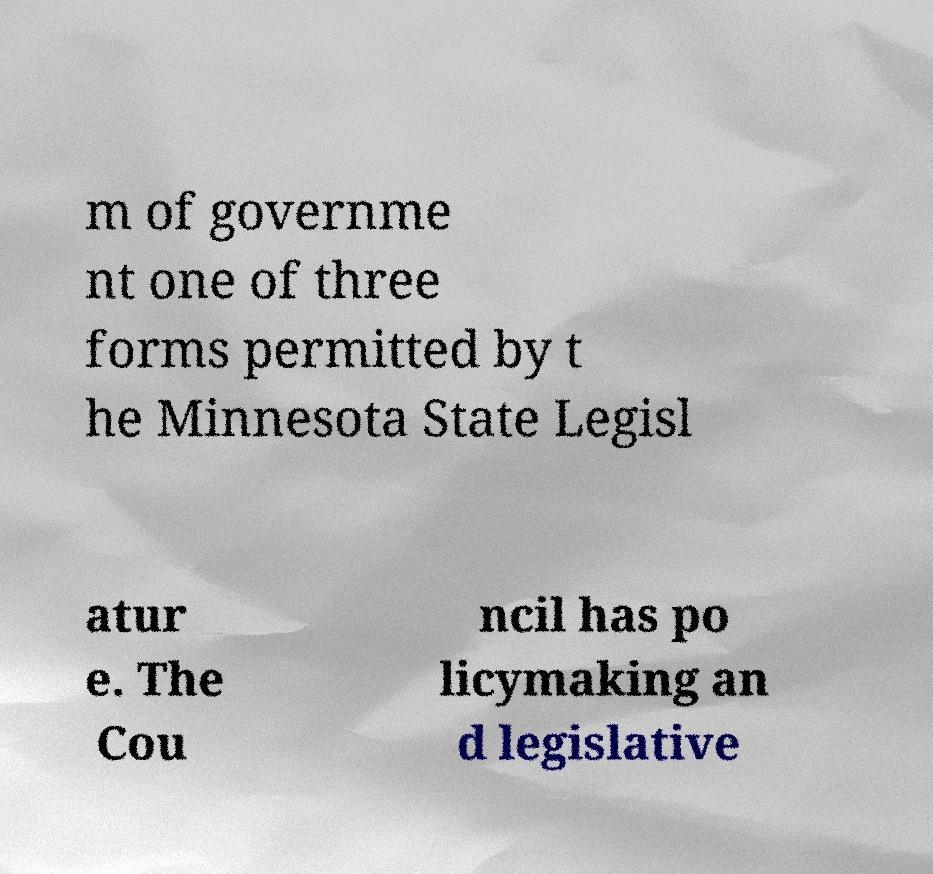Could you extract and type out the text from this image? m of governme nt one of three forms permitted by t he Minnesota State Legisl atur e. The Cou ncil has po licymaking an d legislative 